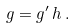Convert formula to latex. <formula><loc_0><loc_0><loc_500><loc_500>g = g ^ { \prime } \, h \, .</formula> 